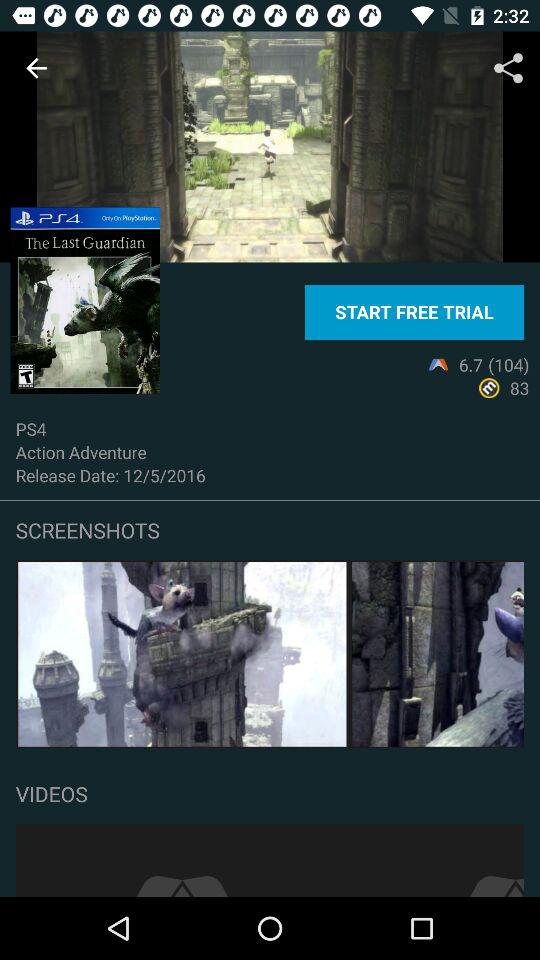What is the name of the game? The name of the game is "The Last Guardian". 